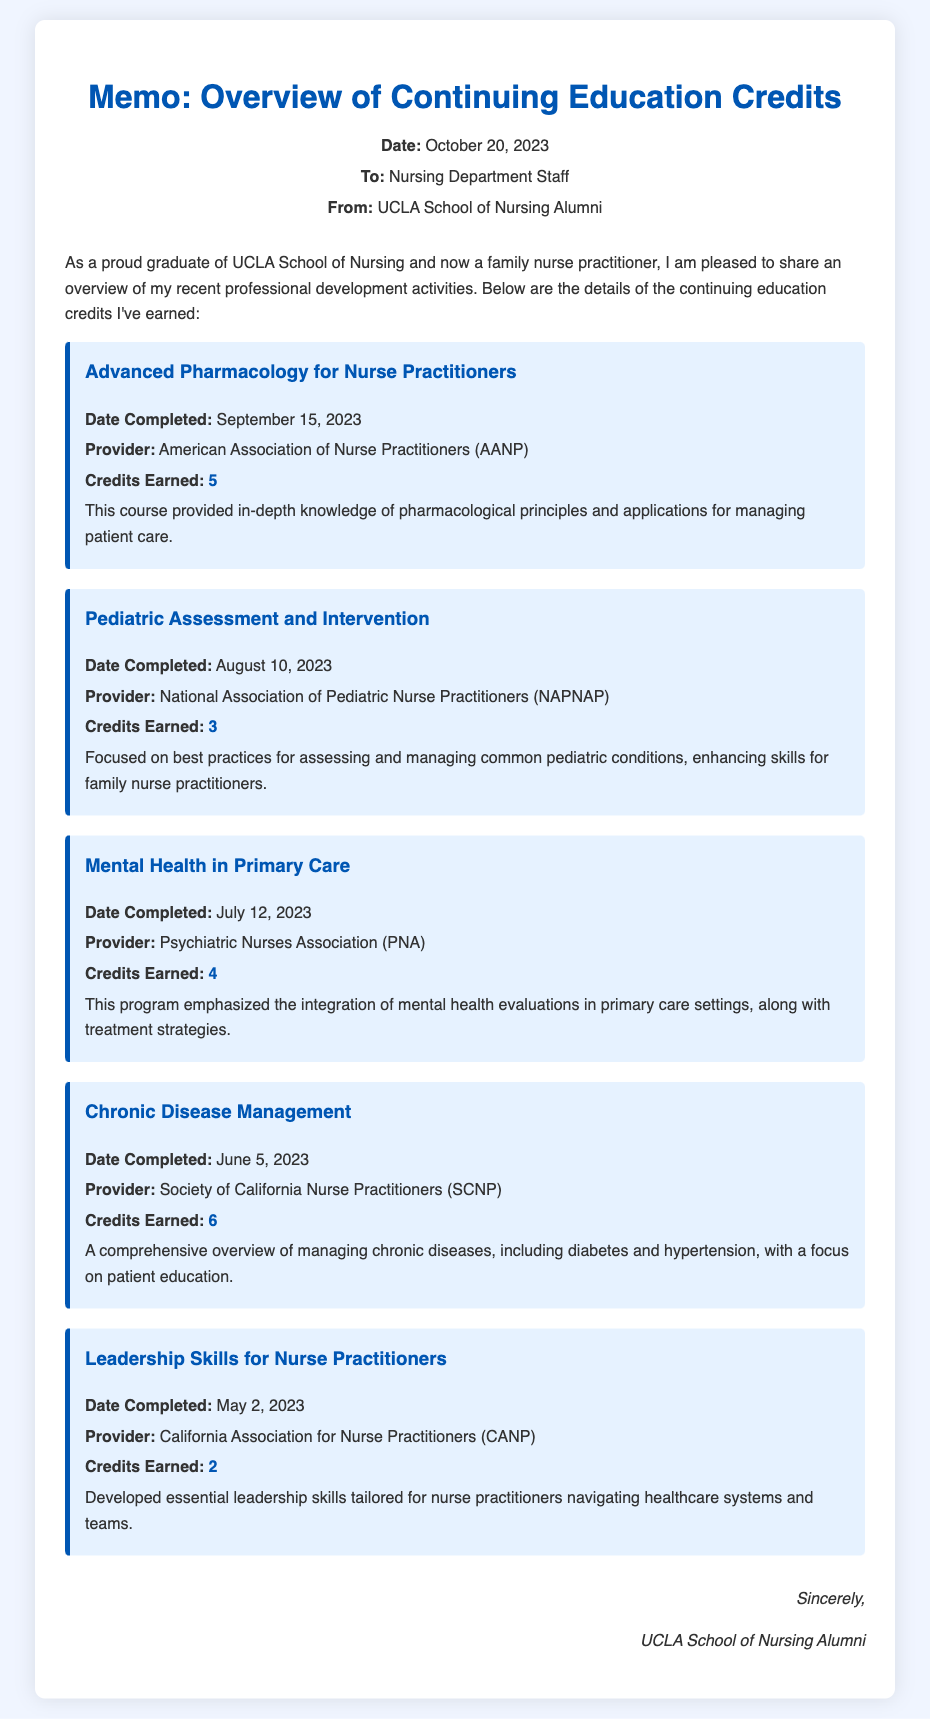what is the title of the memo? The title of the memo is found at the top and states the main topic of the document.
Answer: Overview of Continuing Education Credits who is the memo addressed to? The memo specifies the recipient in the "To:" section.
Answer: Nursing Department Staff how many credits were earned in the "Advanced Pharmacology for Nurse Practitioners" course? The document lists the credits earned for each course, including this one.
Answer: 5 when was the "Pediatric Assessment and Intervention" course completed? The completion date is provided for each course, including this one.
Answer: August 10, 2023 which organization provided the "Leadership Skills for Nurse Practitioners" course? Each course has an associated provider mentioned in the memo.
Answer: California Association for Nurse Practitioners what is the total number of credits earned across all courses listed? By totaling the credits from all courses mentioned, we can find the overall total.
Answer: 20 what notable field does the course "Mental Health in Primary Care" emphasize? Each course description includes a key focus area; this one highlights a specific aspect of care.
Answer: integration of mental health evaluations how many courses listed were completed in the month of June or later? This health professional memo provides the completion dates for each course, which can be tallied.
Answer: 4 